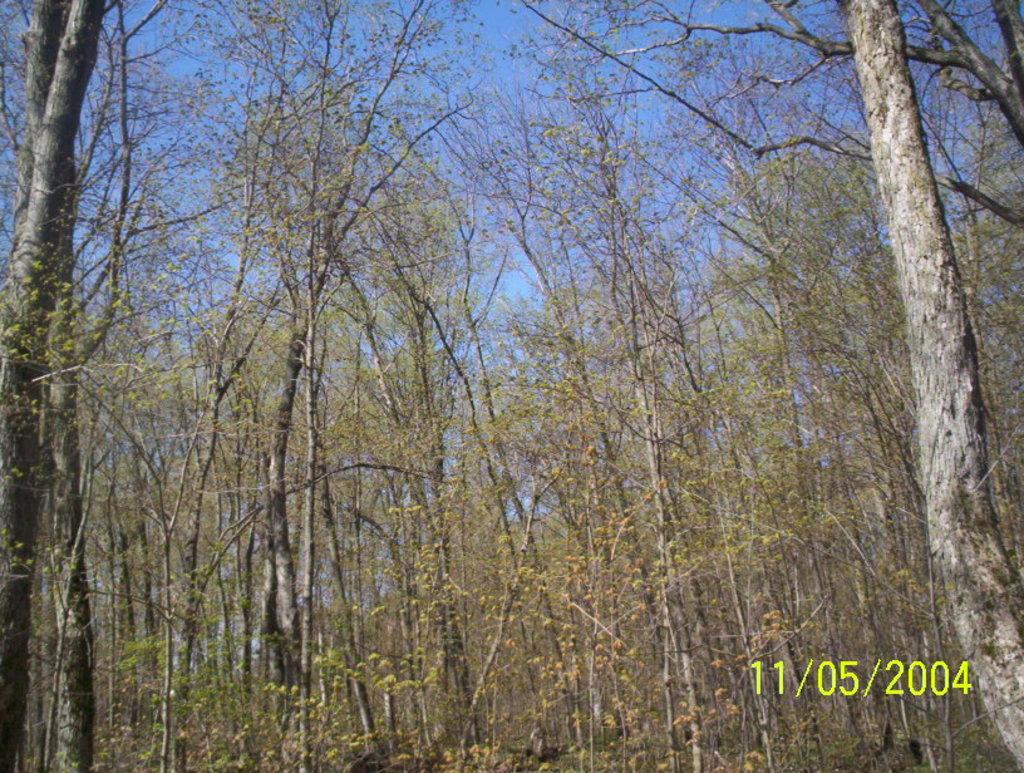Describe this image in one or two sentences. In this image we can see some trees, and the sky, also we can see the text on the image. 